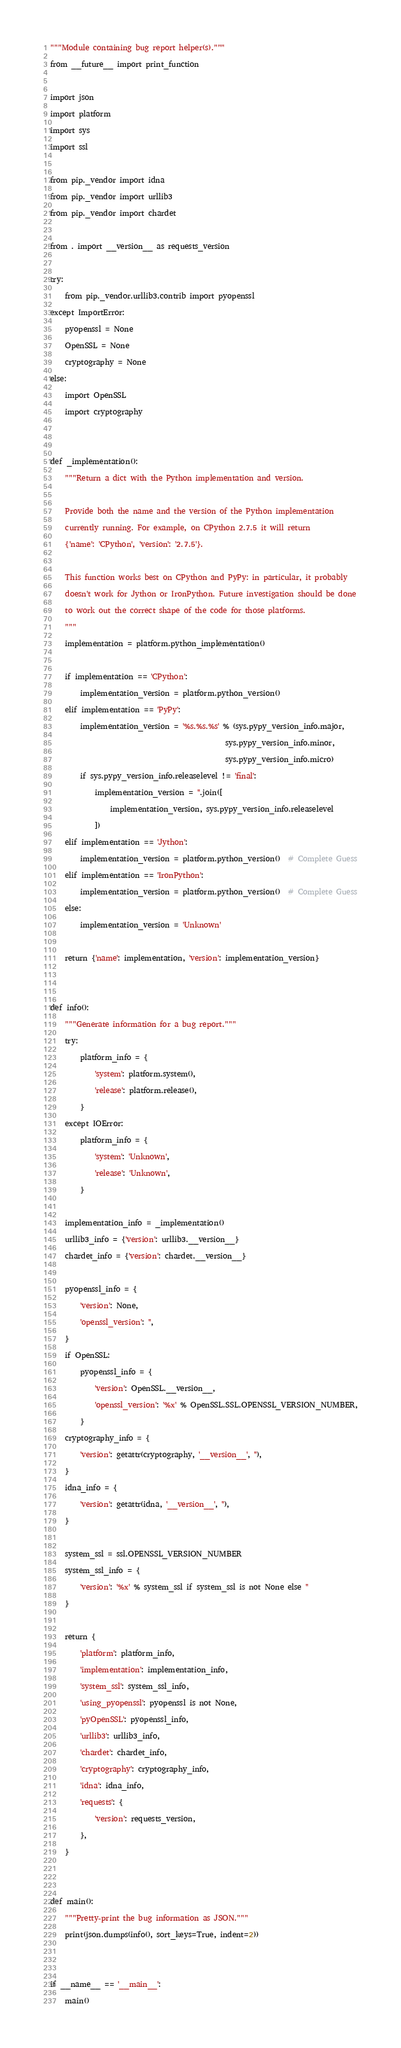<code> <loc_0><loc_0><loc_500><loc_500><_Python_>"""Module containing bug report helper(s)."""
from __future__ import print_function

import json
import platform
import sys
import ssl

from pip._vendor import idna
from pip._vendor import urllib3
from pip._vendor import chardet

from . import __version__ as requests_version

try:
    from pip._vendor.urllib3.contrib import pyopenssl
except ImportError:
    pyopenssl = None
    OpenSSL = None
    cryptography = None
else:
    import OpenSSL
    import cryptography


def _implementation():
    """Return a dict with the Python implementation and version.

    Provide both the name and the version of the Python implementation
    currently running. For example, on CPython 2.7.5 it will return
    {'name': 'CPython', 'version': '2.7.5'}.

    This function works best on CPython and PyPy: in particular, it probably
    doesn't work for Jython or IronPython. Future investigation should be done
    to work out the correct shape of the code for those platforms.
    """
    implementation = platform.python_implementation()

    if implementation == 'CPython':
        implementation_version = platform.python_version()
    elif implementation == 'PyPy':
        implementation_version = '%s.%s.%s' % (sys.pypy_version_info.major,
                                               sys.pypy_version_info.minor,
                                               sys.pypy_version_info.micro)
        if sys.pypy_version_info.releaselevel != 'final':
            implementation_version = ''.join([
                implementation_version, sys.pypy_version_info.releaselevel
            ])
    elif implementation == 'Jython':
        implementation_version = platform.python_version()  # Complete Guess
    elif implementation == 'IronPython':
        implementation_version = platform.python_version()  # Complete Guess
    else:
        implementation_version = 'Unknown'

    return {'name': implementation, 'version': implementation_version}


def info():
    """Generate information for a bug report."""
    try:
        platform_info = {
            'system': platform.system(),
            'release': platform.release(),
        }
    except IOError:
        platform_info = {
            'system': 'Unknown',
            'release': 'Unknown',
        }

    implementation_info = _implementation()
    urllib3_info = {'version': urllib3.__version__}
    chardet_info = {'version': chardet.__version__}

    pyopenssl_info = {
        'version': None,
        'openssl_version': '',
    }
    if OpenSSL:
        pyopenssl_info = {
            'version': OpenSSL.__version__,
            'openssl_version': '%x' % OpenSSL.SSL.OPENSSL_VERSION_NUMBER,
        }
    cryptography_info = {
        'version': getattr(cryptography, '__version__', ''),
    }
    idna_info = {
        'version': getattr(idna, '__version__', ''),
    }

    system_ssl = ssl.OPENSSL_VERSION_NUMBER
    system_ssl_info = {
        'version': '%x' % system_ssl if system_ssl is not None else ''
    }

    return {
        'platform': platform_info,
        'implementation': implementation_info,
        'system_ssl': system_ssl_info,
        'using_pyopenssl': pyopenssl is not None,
        'pyOpenSSL': pyopenssl_info,
        'urllib3': urllib3_info,
        'chardet': chardet_info,
        'cryptography': cryptography_info,
        'idna': idna_info,
        'requests': {
            'version': requests_version,
        },
    }


def main():
    """Pretty-print the bug information as JSON."""
    print(json.dumps(info(), sort_keys=True, indent=2))


if __name__ == '__main__':
    main()
</code> 